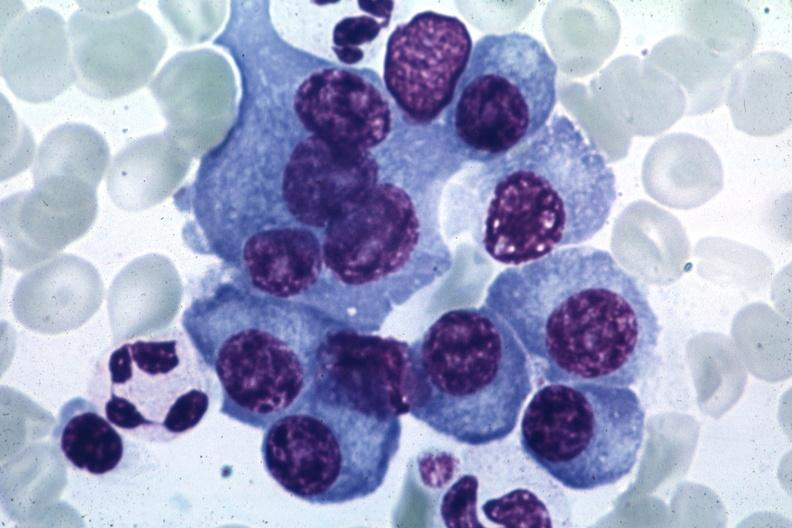s temporal muscle hemorrhage present?
Answer the question using a single word or phrase. No 